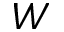Convert formula to latex. <formula><loc_0><loc_0><loc_500><loc_500>W</formula> 